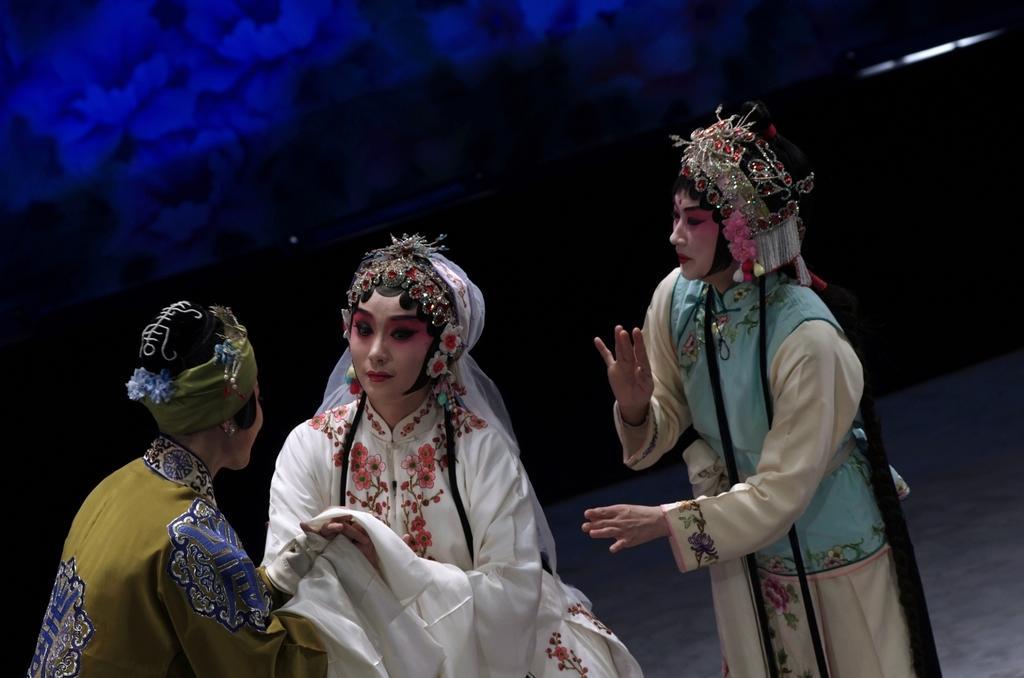Can you describe this image briefly? Here in this picture we can see three women standing on a stage with different kind of dresses on them and they are also wearing head gears on them and performing an act over there. 